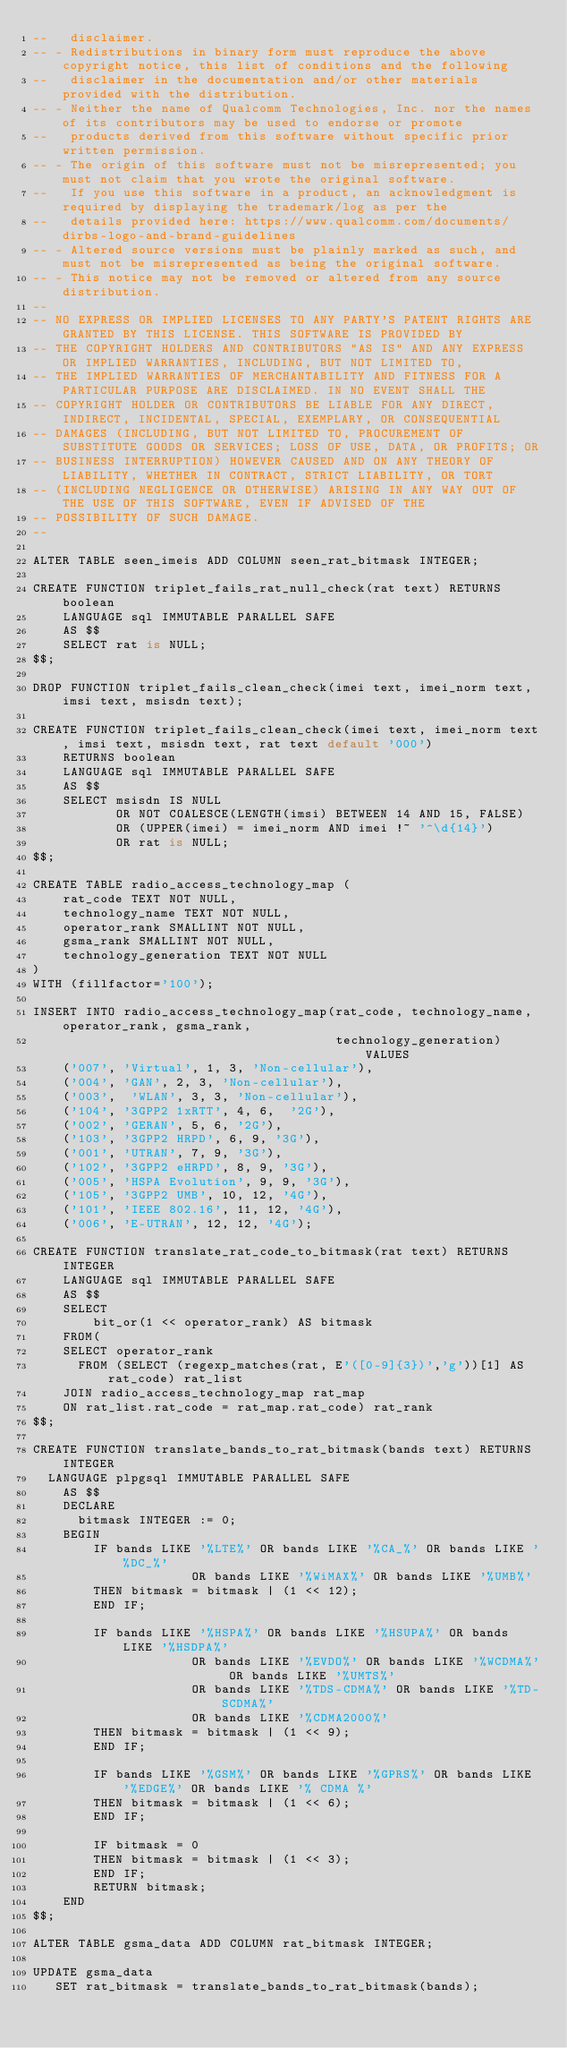Convert code to text. <code><loc_0><loc_0><loc_500><loc_500><_SQL_>--   disclaimer.
-- - Redistributions in binary form must reproduce the above copyright notice, this list of conditions and the following
--   disclaimer in the documentation and/or other materials provided with the distribution.
-- - Neither the name of Qualcomm Technologies, Inc. nor the names of its contributors may be used to endorse or promote
--   products derived from this software without specific prior written permission.
-- - The origin of this software must not be misrepresented; you must not claim that you wrote the original software.
--   If you use this software in a product, an acknowledgment is required by displaying the trademark/log as per the
--   details provided here: https://www.qualcomm.com/documents/dirbs-logo-and-brand-guidelines
-- - Altered source versions must be plainly marked as such, and must not be misrepresented as being the original software.
-- - This notice may not be removed or altered from any source distribution.
--
-- NO EXPRESS OR IMPLIED LICENSES TO ANY PARTY'S PATENT RIGHTS ARE GRANTED BY THIS LICENSE. THIS SOFTWARE IS PROVIDED BY
-- THE COPYRIGHT HOLDERS AND CONTRIBUTORS "AS IS" AND ANY EXPRESS OR IMPLIED WARRANTIES, INCLUDING, BUT NOT LIMITED TO,
-- THE IMPLIED WARRANTIES OF MERCHANTABILITY AND FITNESS FOR A PARTICULAR PURPOSE ARE DISCLAIMED. IN NO EVENT SHALL THE
-- COPYRIGHT HOLDER OR CONTRIBUTORS BE LIABLE FOR ANY DIRECT, INDIRECT, INCIDENTAL, SPECIAL, EXEMPLARY, OR CONSEQUENTIAL
-- DAMAGES (INCLUDING, BUT NOT LIMITED TO, PROCUREMENT OF SUBSTITUTE GOODS OR SERVICES; LOSS OF USE, DATA, OR PROFITS; OR
-- BUSINESS INTERRUPTION) HOWEVER CAUSED AND ON ANY THEORY OF LIABILITY, WHETHER IN CONTRACT, STRICT LIABILITY, OR TORT
-- (INCLUDING NEGLIGENCE OR OTHERWISE) ARISING IN ANY WAY OUT OF THE USE OF THIS SOFTWARE, EVEN IF ADVISED OF THE
-- POSSIBILITY OF SUCH DAMAGE.
--

ALTER TABLE seen_imeis ADD COLUMN seen_rat_bitmask INTEGER;

CREATE FUNCTION triplet_fails_rat_null_check(rat text) RETURNS boolean
    LANGUAGE sql IMMUTABLE PARALLEL SAFE
    AS $$
    SELECT rat is NULL;
$$;

DROP FUNCTION triplet_fails_clean_check(imei text, imei_norm text, imsi text, msisdn text);

CREATE FUNCTION triplet_fails_clean_check(imei text, imei_norm text, imsi text, msisdn text, rat text default '000')
    RETURNS boolean
    LANGUAGE sql IMMUTABLE PARALLEL SAFE
    AS $$
    SELECT msisdn IS NULL
           OR NOT COALESCE(LENGTH(imsi) BETWEEN 14 AND 15, FALSE)
           OR (UPPER(imei) = imei_norm AND imei !~ '^\d{14}')
           OR rat is NULL;
$$;

CREATE TABLE radio_access_technology_map (
    rat_code TEXT NOT NULL,
    technology_name TEXT NOT NULL,
    operator_rank SMALLINT NOT NULL,
    gsma_rank SMALLINT NOT NULL,
    technology_generation TEXT NOT NULL
)
WITH (fillfactor='100');

INSERT INTO radio_access_technology_map(rat_code, technology_name, operator_rank, gsma_rank,
                                        technology_generation) VALUES
    ('007', 'Virtual', 1, 3, 'Non-cellular'),
    ('004', 'GAN', 2, 3, 'Non-cellular'),
    ('003',  'WLAN', 3, 3, 'Non-cellular'),
    ('104', '3GPP2 1xRTT', 4, 6,  '2G'),
    ('002', 'GERAN', 5, 6, '2G'),
    ('103', '3GPP2 HRPD', 6, 9, '3G'),
    ('001', 'UTRAN', 7, 9, '3G'),
    ('102', '3GPP2 eHRPD', 8, 9, '3G'),
    ('005', 'HSPA Evolution', 9, 9, '3G'),
    ('105', '3GPP2 UMB', 10, 12, '4G'),
    ('101', 'IEEE 802.16', 11, 12, '4G'),
    ('006', 'E-UTRAN', 12, 12, '4G');

CREATE FUNCTION translate_rat_code_to_bitmask(rat text) RETURNS INTEGER
    LANGUAGE sql IMMUTABLE PARALLEL SAFE
    AS $$
    SELECT
        bit_or(1 << operator_rank) AS bitmask
    FROM(
    SELECT operator_rank
      FROM (SELECT (regexp_matches(rat, E'([0-9]{3})','g'))[1] AS rat_code) rat_list
    JOIN radio_access_technology_map rat_map
    ON rat_list.rat_code = rat_map.rat_code) rat_rank
$$;

CREATE FUNCTION translate_bands_to_rat_bitmask(bands text) RETURNS INTEGER
  LANGUAGE plpgsql IMMUTABLE PARALLEL SAFE
    AS $$
    DECLARE
      bitmask INTEGER := 0;
    BEGIN
        IF bands LIKE '%LTE%' OR bands LIKE '%CA_%' OR bands LIKE '%DC_%'
                     OR bands LIKE '%WiMAX%' OR bands LIKE '%UMB%'
        THEN bitmask = bitmask | (1 << 12);
        END IF;

        IF bands LIKE '%HSPA%' OR bands LIKE '%HSUPA%' OR bands LIKE '%HSDPA%'
                     OR bands LIKE '%EVDO%' OR bands LIKE '%WCDMA%' OR bands LIKE '%UMTS%'
                     OR bands LIKE '%TDS-CDMA%' OR bands LIKE '%TD-SCDMA%'
                     OR bands LIKE '%CDMA2000%'
        THEN bitmask = bitmask | (1 << 9);
        END IF;

        IF bands LIKE '%GSM%' OR bands LIKE '%GPRS%' OR bands LIKE '%EDGE%' OR bands LIKE '% CDMA %'
        THEN bitmask = bitmask | (1 << 6);
        END IF;

        IF bitmask = 0
        THEN bitmask = bitmask | (1 << 3);
        END IF;
        RETURN bitmask;
    END
$$;

ALTER TABLE gsma_data ADD COLUMN rat_bitmask INTEGER;

UPDATE gsma_data
   SET rat_bitmask = translate_bands_to_rat_bitmask(bands);
</code> 